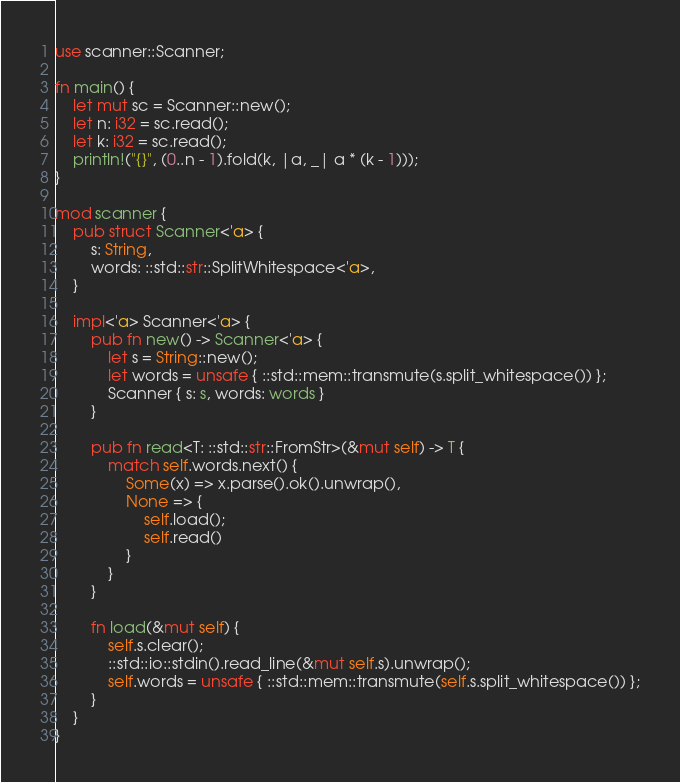<code> <loc_0><loc_0><loc_500><loc_500><_Rust_>use scanner::Scanner;

fn main() {
    let mut sc = Scanner::new();
    let n: i32 = sc.read();
    let k: i32 = sc.read();
    println!("{}", (0..n - 1).fold(k, |a, _| a * (k - 1)));
}

mod scanner {
    pub struct Scanner<'a> {
        s: String,
        words: ::std::str::SplitWhitespace<'a>,
    }

    impl<'a> Scanner<'a> {
        pub fn new() -> Scanner<'a> {
            let s = String::new();
            let words = unsafe { ::std::mem::transmute(s.split_whitespace()) };
            Scanner { s: s, words: words }
        }

        pub fn read<T: ::std::str::FromStr>(&mut self) -> T {
            match self.words.next() {
                Some(x) => x.parse().ok().unwrap(),
                None => {
                    self.load();
                    self.read()
                }
            }
        }

        fn load(&mut self) {
            self.s.clear();
            ::std::io::stdin().read_line(&mut self.s).unwrap();
            self.words = unsafe { ::std::mem::transmute(self.s.split_whitespace()) };
        }
    }
}
</code> 